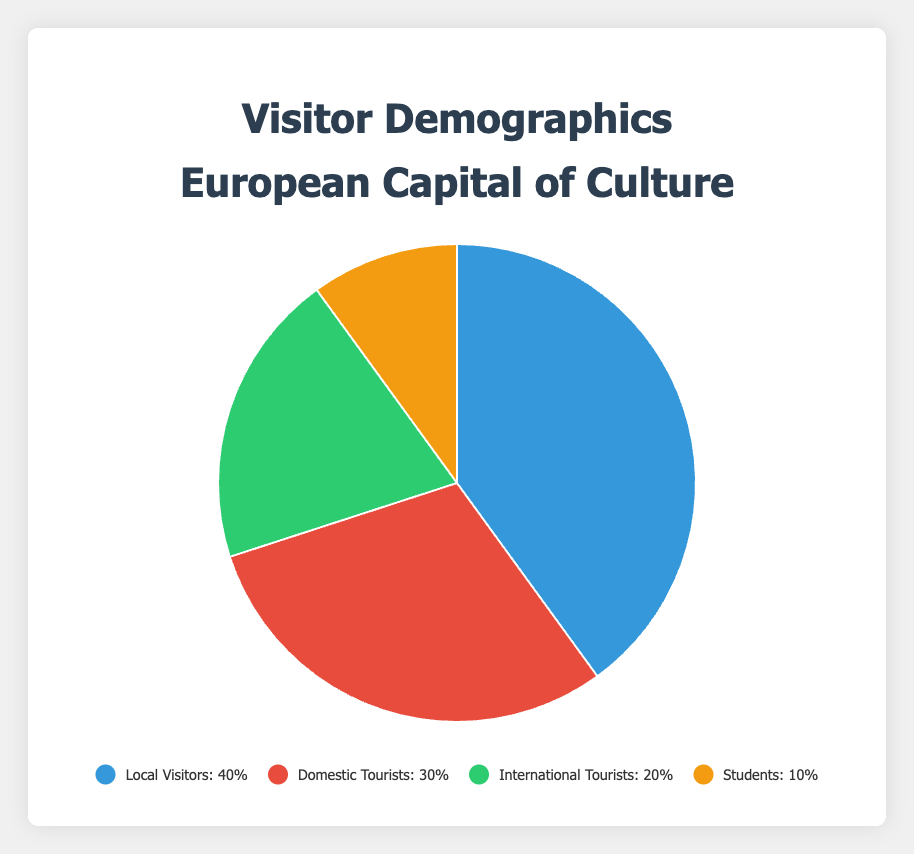what percentage of visitors are not local visitors? The total percentage of all visitors is 100%. Local visitors make up 40% of the visitors. Subtract this from 100% to get the percentage of visitors who are not local visitors. 100% - 40% = 60%.
Answer: 60% Which category has the second highest percentage of visitors? According to the data, Local Visitors have the highest percentage at 40%. The next highest is Domestic Tourists at 30%.
Answer: Domestic Tourists What is the total percentage of international tourists and students combined? Add the percentages of International Tourists (20%) and Students (10%). 20% + 10% = 30%.
Answer: 30% How does the percentage of domestic tourists compare to international tourists? According to the data, Domestic Tourists make up 30% while International Tourists make up 20%. Therefore, Domestic Tourists account for a higher percentage than International Tourists by 10%.
Answer: Domestic Tourists have 10% more Which color represents the category with the smallest percentage? According to the chart's legend, the category with the smallest percentage is Students with 10%. The Students category is represented by the color corresponding to the last listed color, which is yellow.
Answer: Yellow What is the difference between the percentages of local visitors and students? Subtract the percentage of Students (10%) from the percentage of Local Visitors (40%). 40% - 10% = 30%.
Answer: 30% Arrange the visitor categories in order from the highest to the lowest percentage. According to the data, the categories in order from highest to lowest are: Local Visitors (40%), Domestic Tourists (30%), International Tourists (20%), and Students (10%).
Answer: Local Visitors, Domestic Tourists, International Tourists, Students What percentage of the visitors are either domestic tourists or local visitors? Add the percentages of Domestic Tourists (30%) and Local Visitors (40%). 30% + 40% = 70%.
Answer: 70% Identify the category of visitors represented by the green segment of the pie chart. According to the chart, the category represented by the green segment is International Tourists, which constitutes 20% of the visitors.
Answer: International Tourists How many categories have a percentage higher than 25%? According to the data, Local Visitors (40%) and Domestic Tourists (30%) each have percentages higher than 25%. There are 2 such categories.
Answer: 2 